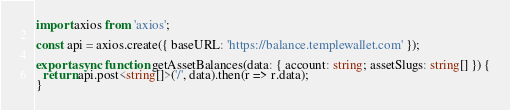<code> <loc_0><loc_0><loc_500><loc_500><_TypeScript_>import axios from 'axios';

const api = axios.create({ baseURL: 'https://balance.templewallet.com' });

export async function getAssetBalances(data: { account: string; assetSlugs: string[] }) {
  return api.post<string[]>('/', data).then(r => r.data);
}
</code> 